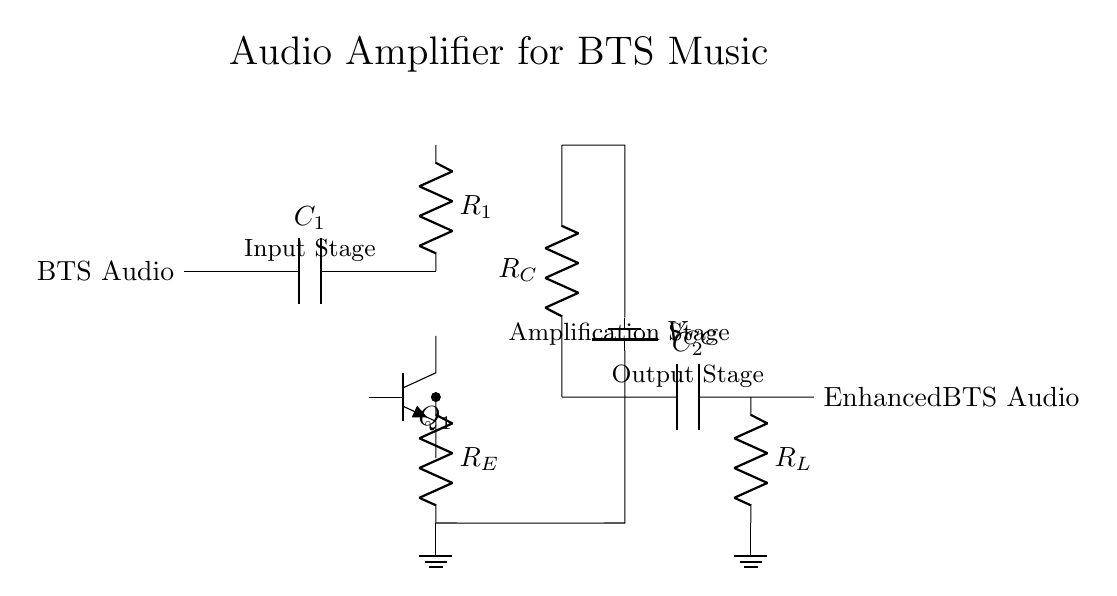What is the main function of the circuit? The main function of the circuit is to amplify the audio signal, enhancing the playback quality of BTS music. This is evident from the labeling and the presence of components geared towards amplification.
Answer: Amplification What type of transistor is used in this amplifier? The transistor shown in the circuit is an npn transistor, indicated by the label next to the transistor symbol in the diagram.
Answer: Npn What is the role of capacitor C1? Capacitor C1 is positioned at the input stage, serving to block any DC component from the BTS audio signal while allowing AC (the audio signal) to pass through, which is essential for audio processing.
Answer: Coupling How is the emitter resistor R_E connected? The emitter resistor R_E is connected between the emitter of the transistor and ground, establishing a feedback mechanism that stabilizes the amplifier's performance by controlling the emitter current.
Answer: To ground What is the purpose of the power supply voltage, V_CC? The power supply voltage V_CC provides the necessary voltage for the active components, particularly the transistor, to operate correctly and amplify the input signal to an enhanced output level.
Answer: Power source Which component is responsible for the output audio quality enhancement? The load resistor R_L, which is connected at the output stage, is responsible for ensuring that the audio signal is delivered properly to the output, thus playing a critical role in the overall sound quality.
Answer: Load resistor How many stages are present in this audio amplifier circuit? There are three stages in the audio amplifier circuit: the input stage, the amplification stage, and the output stage, each serving distinct functions in processing the audio signal.
Answer: Three 